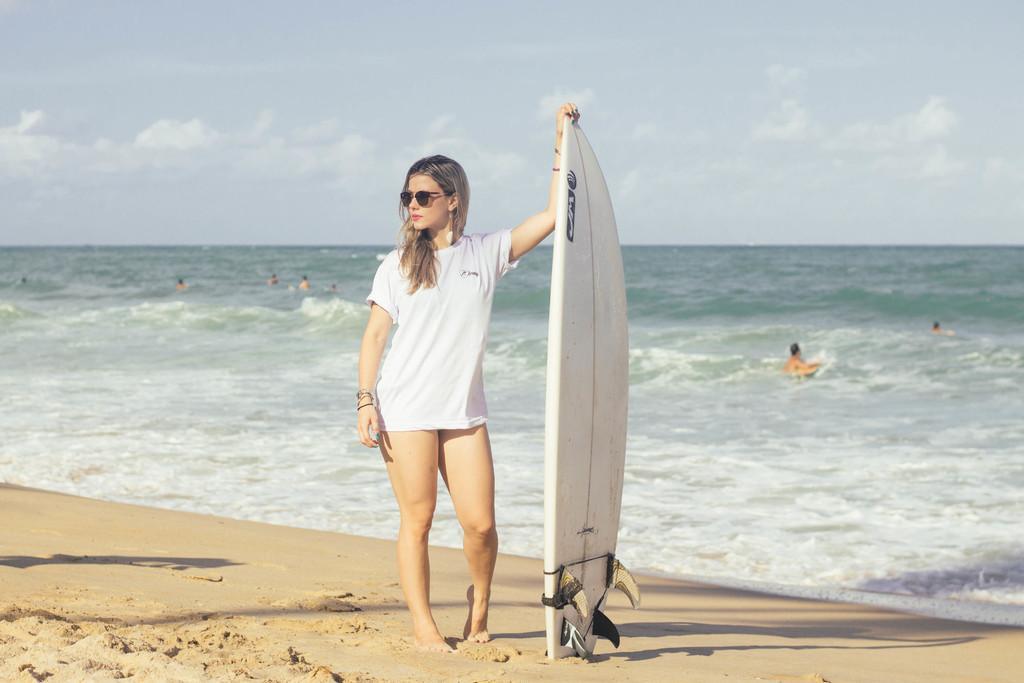Can you describe this image briefly? Here we can see a woman standing near the beach with surfing board in her hand and behind her we can see cloudy sky 